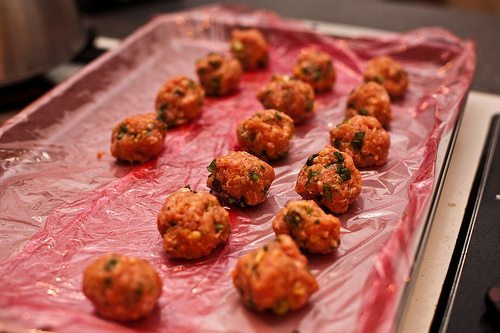<image>
Is there a meatball in the shrink wrap? Yes. The meatball is contained within or inside the shrink wrap, showing a containment relationship. Is there a meatballs in front of the tray? No. The meatballs is not in front of the tray. The spatial positioning shows a different relationship between these objects. 